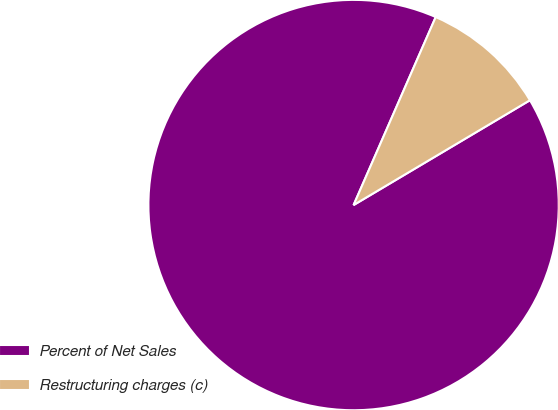<chart> <loc_0><loc_0><loc_500><loc_500><pie_chart><fcel>Percent of Net Sales<fcel>Restructuring charges (c)<nl><fcel>90.09%<fcel>9.91%<nl></chart> 